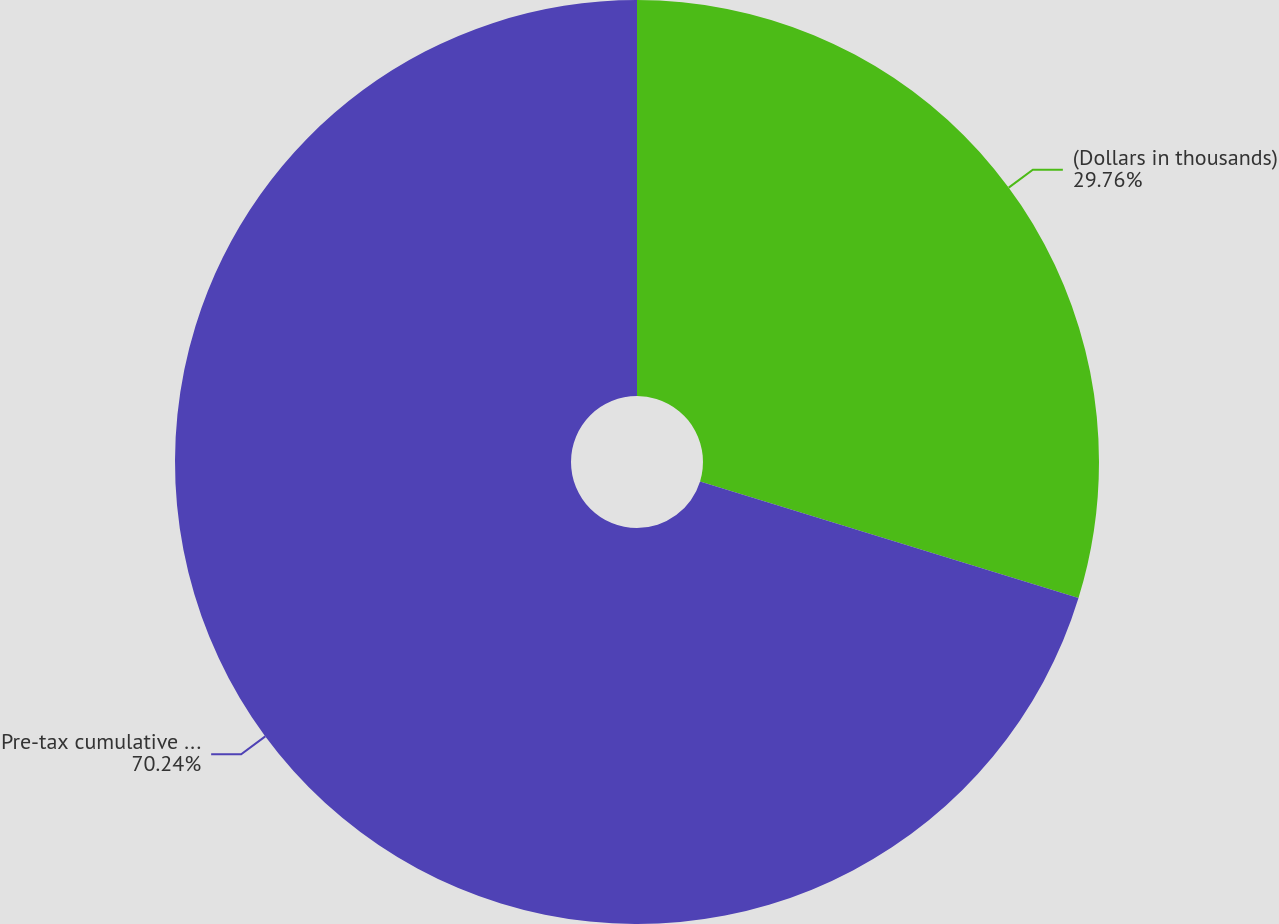Convert chart to OTSL. <chart><loc_0><loc_0><loc_500><loc_500><pie_chart><fcel>(Dollars in thousands)<fcel>Pre-tax cumulative unrealized<nl><fcel>29.76%<fcel>70.24%<nl></chart> 